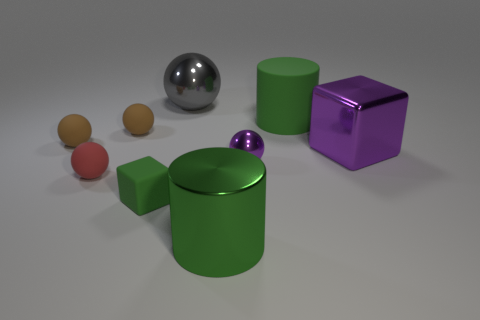How many brown balls must be subtracted to get 1 brown balls? 1 Subtract all cubes. How many objects are left? 7 Subtract 2 cubes. How many cubes are left? 0 Subtract all purple balls. Subtract all blue blocks. How many balls are left? 4 Subtract all gray cubes. How many gray cylinders are left? 0 Subtract all matte objects. Subtract all large purple metallic blocks. How many objects are left? 3 Add 7 small purple metal objects. How many small purple metal objects are left? 8 Add 8 green rubber objects. How many green rubber objects exist? 10 Subtract all purple spheres. How many spheres are left? 4 Subtract all tiny purple balls. How many balls are left? 4 